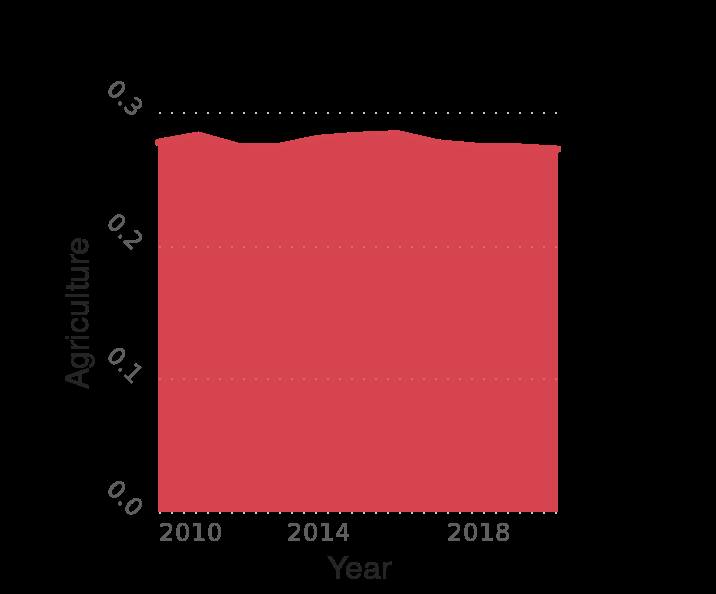<image>
Describe the following image in detail Here a is a area diagram labeled Peru : Distribution of employment by economic sector from 2010 to 2020. The x-axis shows Year while the y-axis measures Agriculture. Is 0.3 the upper limit for the figures? Yes, the figures do not exceed 0.3. 